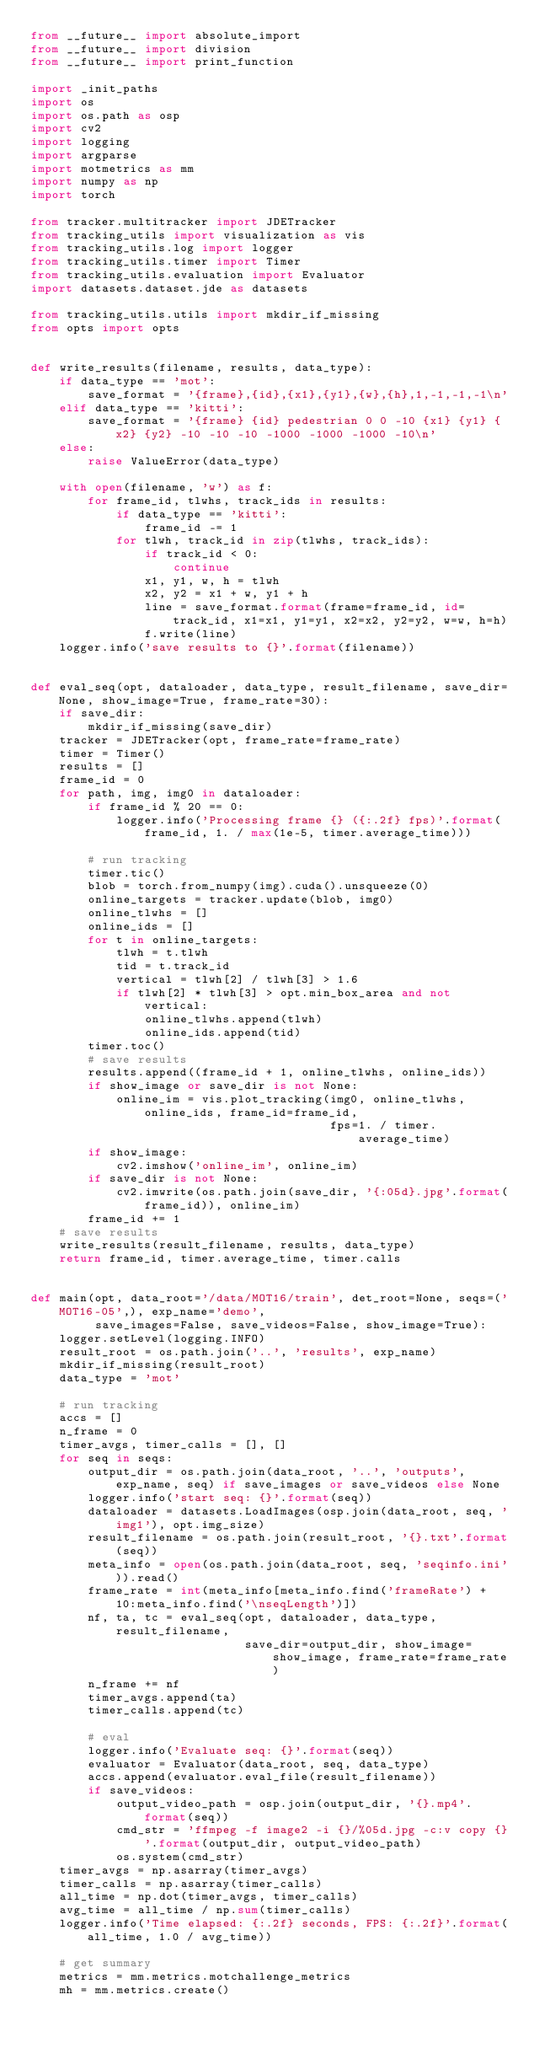<code> <loc_0><loc_0><loc_500><loc_500><_Python_>from __future__ import absolute_import
from __future__ import division
from __future__ import print_function

import _init_paths
import os
import os.path as osp
import cv2
import logging
import argparse
import motmetrics as mm
import numpy as np
import torch

from tracker.multitracker import JDETracker
from tracking_utils import visualization as vis
from tracking_utils.log import logger
from tracking_utils.timer import Timer
from tracking_utils.evaluation import Evaluator
import datasets.dataset.jde as datasets

from tracking_utils.utils import mkdir_if_missing
from opts import opts


def write_results(filename, results, data_type):
    if data_type == 'mot':
        save_format = '{frame},{id},{x1},{y1},{w},{h},1,-1,-1,-1\n'
    elif data_type == 'kitti':
        save_format = '{frame} {id} pedestrian 0 0 -10 {x1} {y1} {x2} {y2} -10 -10 -10 -1000 -1000 -1000 -10\n'
    else:
        raise ValueError(data_type)

    with open(filename, 'w') as f:
        for frame_id, tlwhs, track_ids in results:
            if data_type == 'kitti':
                frame_id -= 1
            for tlwh, track_id in zip(tlwhs, track_ids):
                if track_id < 0:
                    continue
                x1, y1, w, h = tlwh
                x2, y2 = x1 + w, y1 + h
                line = save_format.format(frame=frame_id, id=track_id, x1=x1, y1=y1, x2=x2, y2=y2, w=w, h=h)
                f.write(line)
    logger.info('save results to {}'.format(filename))


def eval_seq(opt, dataloader, data_type, result_filename, save_dir=None, show_image=True, frame_rate=30):
    if save_dir:
        mkdir_if_missing(save_dir)
    tracker = JDETracker(opt, frame_rate=frame_rate)
    timer = Timer()
    results = []
    frame_id = 0
    for path, img, img0 in dataloader:
        if frame_id % 20 == 0:
            logger.info('Processing frame {} ({:.2f} fps)'.format(frame_id, 1. / max(1e-5, timer.average_time)))

        # run tracking
        timer.tic()
        blob = torch.from_numpy(img).cuda().unsqueeze(0)
        online_targets = tracker.update(blob, img0)
        online_tlwhs = []
        online_ids = []
        for t in online_targets:
            tlwh = t.tlwh
            tid = t.track_id
            vertical = tlwh[2] / tlwh[3] > 1.6
            if tlwh[2] * tlwh[3] > opt.min_box_area and not vertical:
                online_tlwhs.append(tlwh)
                online_ids.append(tid)
        timer.toc()
        # save results
        results.append((frame_id + 1, online_tlwhs, online_ids))
        if show_image or save_dir is not None:
            online_im = vis.plot_tracking(img0, online_tlwhs, online_ids, frame_id=frame_id,
                                          fps=1. / timer.average_time)
        if show_image:
            cv2.imshow('online_im', online_im)
        if save_dir is not None:
            cv2.imwrite(os.path.join(save_dir, '{:05d}.jpg'.format(frame_id)), online_im)
        frame_id += 1
    # save results
    write_results(result_filename, results, data_type)
    return frame_id, timer.average_time, timer.calls


def main(opt, data_root='/data/MOT16/train', det_root=None, seqs=('MOT16-05',), exp_name='demo',
         save_images=False, save_videos=False, show_image=True):
    logger.setLevel(logging.INFO)
    result_root = os.path.join('..', 'results', exp_name)
    mkdir_if_missing(result_root)
    data_type = 'mot'

    # run tracking
    accs = []
    n_frame = 0
    timer_avgs, timer_calls = [], []
    for seq in seqs:
        output_dir = os.path.join(data_root, '..', 'outputs', exp_name, seq) if save_images or save_videos else None
        logger.info('start seq: {}'.format(seq))
        dataloader = datasets.LoadImages(osp.join(data_root, seq, 'img1'), opt.img_size)
        result_filename = os.path.join(result_root, '{}.txt'.format(seq))
        meta_info = open(os.path.join(data_root, seq, 'seqinfo.ini')).read()
        frame_rate = int(meta_info[meta_info.find('frameRate') + 10:meta_info.find('\nseqLength')])
        nf, ta, tc = eval_seq(opt, dataloader, data_type, result_filename,
                              save_dir=output_dir, show_image=show_image, frame_rate=frame_rate)
        n_frame += nf
        timer_avgs.append(ta)
        timer_calls.append(tc)

        # eval
        logger.info('Evaluate seq: {}'.format(seq))
        evaluator = Evaluator(data_root, seq, data_type)
        accs.append(evaluator.eval_file(result_filename))
        if save_videos:
            output_video_path = osp.join(output_dir, '{}.mp4'.format(seq))
            cmd_str = 'ffmpeg -f image2 -i {}/%05d.jpg -c:v copy {}'.format(output_dir, output_video_path)
            os.system(cmd_str)
    timer_avgs = np.asarray(timer_avgs)
    timer_calls = np.asarray(timer_calls)
    all_time = np.dot(timer_avgs, timer_calls)
    avg_time = all_time / np.sum(timer_calls)
    logger.info('Time elapsed: {:.2f} seconds, FPS: {:.2f}'.format(all_time, 1.0 / avg_time))

    # get summary
    metrics = mm.metrics.motchallenge_metrics
    mh = mm.metrics.create()</code> 